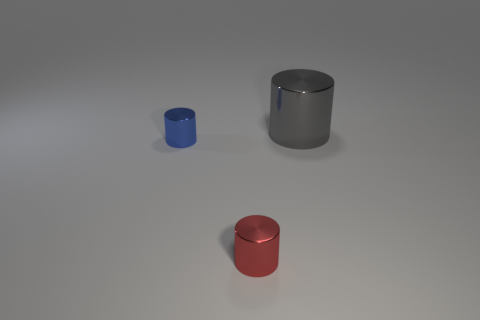Subtract all small cylinders. How many cylinders are left? 1 Add 2 small red cylinders. How many objects exist? 5 Subtract 1 cylinders. How many cylinders are left? 2 Subtract all purple cubes. How many yellow cylinders are left? 0 Subtract all metallic things. Subtract all large cyan shiny blocks. How many objects are left? 0 Add 3 metal things. How many metal things are left? 6 Add 2 red metal things. How many red metal things exist? 3 Subtract all gray cylinders. How many cylinders are left? 2 Subtract 0 red blocks. How many objects are left? 3 Subtract all cyan cylinders. Subtract all cyan balls. How many cylinders are left? 3 